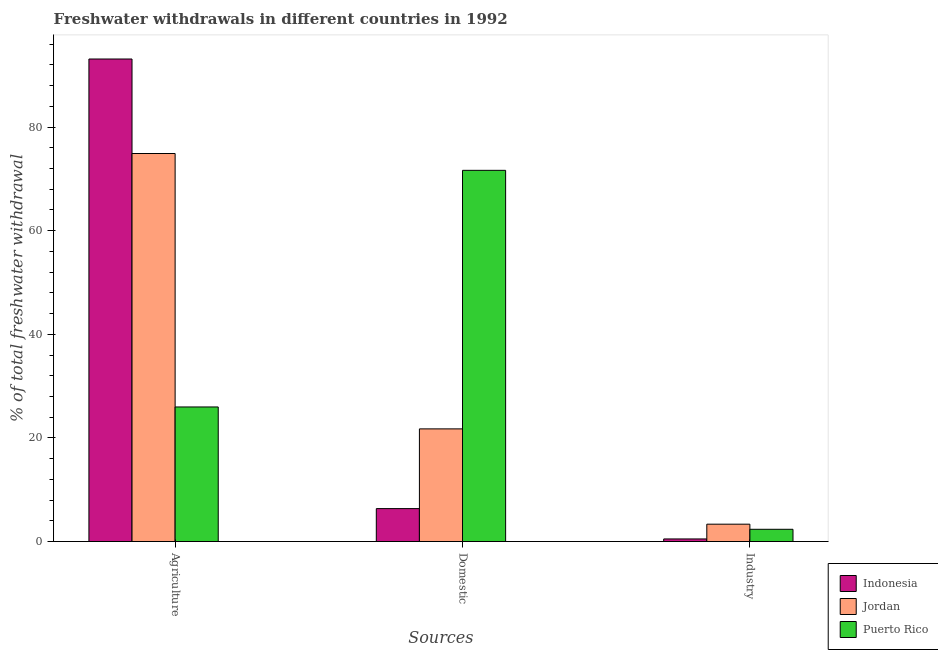How many groups of bars are there?
Provide a short and direct response. 3. How many bars are there on the 1st tick from the left?
Your answer should be compact. 3. How many bars are there on the 3rd tick from the right?
Offer a very short reply. 3. What is the label of the 3rd group of bars from the left?
Provide a succinct answer. Industry. What is the percentage of freshwater withdrawal for agriculture in Indonesia?
Your answer should be compact. 93.14. Across all countries, what is the maximum percentage of freshwater withdrawal for domestic purposes?
Offer a very short reply. 71.65. Across all countries, what is the minimum percentage of freshwater withdrawal for domestic purposes?
Offer a very short reply. 6.36. In which country was the percentage of freshwater withdrawal for industry maximum?
Make the answer very short. Jordan. In which country was the percentage of freshwater withdrawal for agriculture minimum?
Ensure brevity in your answer.  Puerto Rico. What is the total percentage of freshwater withdrawal for agriculture in the graph?
Ensure brevity in your answer.  194.02. What is the difference between the percentage of freshwater withdrawal for agriculture in Indonesia and that in Puerto Rico?
Your response must be concise. 67.16. What is the difference between the percentage of freshwater withdrawal for industry in Jordan and the percentage of freshwater withdrawal for agriculture in Indonesia?
Offer a very short reply. -89.79. What is the average percentage of freshwater withdrawal for industry per country?
Keep it short and to the point. 2.08. What is the difference between the percentage of freshwater withdrawal for domestic purposes and percentage of freshwater withdrawal for agriculture in Jordan?
Your response must be concise. -53.15. What is the ratio of the percentage of freshwater withdrawal for industry in Puerto Rico to that in Indonesia?
Give a very brief answer. 4.68. Is the percentage of freshwater withdrawal for agriculture in Jordan less than that in Indonesia?
Your answer should be compact. Yes. What is the difference between the highest and the second highest percentage of freshwater withdrawal for industry?
Ensure brevity in your answer.  0.99. What is the difference between the highest and the lowest percentage of freshwater withdrawal for domestic purposes?
Provide a short and direct response. 65.29. In how many countries, is the percentage of freshwater withdrawal for industry greater than the average percentage of freshwater withdrawal for industry taken over all countries?
Keep it short and to the point. 2. Is the sum of the percentage of freshwater withdrawal for domestic purposes in Jordan and Indonesia greater than the maximum percentage of freshwater withdrawal for industry across all countries?
Keep it short and to the point. Yes. What does the 3rd bar from the left in Industry represents?
Ensure brevity in your answer.  Puerto Rico. What does the 2nd bar from the right in Agriculture represents?
Your answer should be very brief. Jordan. Are the values on the major ticks of Y-axis written in scientific E-notation?
Provide a succinct answer. No. Does the graph contain any zero values?
Your answer should be compact. No. Does the graph contain grids?
Your response must be concise. No. Where does the legend appear in the graph?
Provide a short and direct response. Bottom right. How many legend labels are there?
Offer a very short reply. 3. What is the title of the graph?
Ensure brevity in your answer.  Freshwater withdrawals in different countries in 1992. What is the label or title of the X-axis?
Make the answer very short. Sources. What is the label or title of the Y-axis?
Offer a terse response. % of total freshwater withdrawal. What is the % of total freshwater withdrawal in Indonesia in Agriculture?
Provide a succinct answer. 93.14. What is the % of total freshwater withdrawal in Jordan in Agriculture?
Make the answer very short. 74.9. What is the % of total freshwater withdrawal of Puerto Rico in Agriculture?
Make the answer very short. 25.98. What is the % of total freshwater withdrawal in Indonesia in Domestic?
Make the answer very short. 6.36. What is the % of total freshwater withdrawal of Jordan in Domestic?
Your answer should be compact. 21.75. What is the % of total freshwater withdrawal of Puerto Rico in Domestic?
Give a very brief answer. 71.65. What is the % of total freshwater withdrawal in Indonesia in Industry?
Your answer should be compact. 0.51. What is the % of total freshwater withdrawal in Jordan in Industry?
Make the answer very short. 3.35. What is the % of total freshwater withdrawal of Puerto Rico in Industry?
Your answer should be compact. 2.37. Across all Sources, what is the maximum % of total freshwater withdrawal in Indonesia?
Your answer should be very brief. 93.14. Across all Sources, what is the maximum % of total freshwater withdrawal of Jordan?
Give a very brief answer. 74.9. Across all Sources, what is the maximum % of total freshwater withdrawal in Puerto Rico?
Provide a short and direct response. 71.65. Across all Sources, what is the minimum % of total freshwater withdrawal in Indonesia?
Ensure brevity in your answer.  0.51. Across all Sources, what is the minimum % of total freshwater withdrawal in Jordan?
Make the answer very short. 3.35. Across all Sources, what is the minimum % of total freshwater withdrawal in Puerto Rico?
Ensure brevity in your answer.  2.37. What is the total % of total freshwater withdrawal in Indonesia in the graph?
Give a very brief answer. 100.01. What is the total % of total freshwater withdrawal of Jordan in the graph?
Ensure brevity in your answer.  100. What is the total % of total freshwater withdrawal in Puerto Rico in the graph?
Your answer should be compact. 100. What is the difference between the % of total freshwater withdrawal in Indonesia in Agriculture and that in Domestic?
Your answer should be very brief. 86.78. What is the difference between the % of total freshwater withdrawal in Jordan in Agriculture and that in Domestic?
Your answer should be very brief. 53.15. What is the difference between the % of total freshwater withdrawal of Puerto Rico in Agriculture and that in Domestic?
Your answer should be compact. -45.67. What is the difference between the % of total freshwater withdrawal of Indonesia in Agriculture and that in Industry?
Your response must be concise. 92.63. What is the difference between the % of total freshwater withdrawal in Jordan in Agriculture and that in Industry?
Your answer should be compact. 71.55. What is the difference between the % of total freshwater withdrawal in Puerto Rico in Agriculture and that in Industry?
Keep it short and to the point. 23.61. What is the difference between the % of total freshwater withdrawal in Indonesia in Domestic and that in Industry?
Your answer should be very brief. 5.86. What is the difference between the % of total freshwater withdrawal in Jordan in Domestic and that in Industry?
Keep it short and to the point. 18.4. What is the difference between the % of total freshwater withdrawal of Puerto Rico in Domestic and that in Industry?
Ensure brevity in your answer.  69.28. What is the difference between the % of total freshwater withdrawal in Indonesia in Agriculture and the % of total freshwater withdrawal in Jordan in Domestic?
Make the answer very short. 71.39. What is the difference between the % of total freshwater withdrawal of Indonesia in Agriculture and the % of total freshwater withdrawal of Puerto Rico in Domestic?
Give a very brief answer. 21.49. What is the difference between the % of total freshwater withdrawal in Jordan in Agriculture and the % of total freshwater withdrawal in Puerto Rico in Domestic?
Your response must be concise. 3.25. What is the difference between the % of total freshwater withdrawal in Indonesia in Agriculture and the % of total freshwater withdrawal in Jordan in Industry?
Keep it short and to the point. 89.79. What is the difference between the % of total freshwater withdrawal in Indonesia in Agriculture and the % of total freshwater withdrawal in Puerto Rico in Industry?
Provide a succinct answer. 90.77. What is the difference between the % of total freshwater withdrawal in Jordan in Agriculture and the % of total freshwater withdrawal in Puerto Rico in Industry?
Ensure brevity in your answer.  72.53. What is the difference between the % of total freshwater withdrawal of Indonesia in Domestic and the % of total freshwater withdrawal of Jordan in Industry?
Provide a succinct answer. 3.01. What is the difference between the % of total freshwater withdrawal in Indonesia in Domestic and the % of total freshwater withdrawal in Puerto Rico in Industry?
Provide a succinct answer. 3.99. What is the difference between the % of total freshwater withdrawal in Jordan in Domestic and the % of total freshwater withdrawal in Puerto Rico in Industry?
Offer a terse response. 19.38. What is the average % of total freshwater withdrawal of Indonesia per Sources?
Provide a short and direct response. 33.34. What is the average % of total freshwater withdrawal in Jordan per Sources?
Your answer should be very brief. 33.33. What is the average % of total freshwater withdrawal of Puerto Rico per Sources?
Your answer should be compact. 33.33. What is the difference between the % of total freshwater withdrawal in Indonesia and % of total freshwater withdrawal in Jordan in Agriculture?
Your answer should be very brief. 18.24. What is the difference between the % of total freshwater withdrawal in Indonesia and % of total freshwater withdrawal in Puerto Rico in Agriculture?
Offer a very short reply. 67.16. What is the difference between the % of total freshwater withdrawal of Jordan and % of total freshwater withdrawal of Puerto Rico in Agriculture?
Offer a very short reply. 48.92. What is the difference between the % of total freshwater withdrawal of Indonesia and % of total freshwater withdrawal of Jordan in Domestic?
Ensure brevity in your answer.  -15.39. What is the difference between the % of total freshwater withdrawal in Indonesia and % of total freshwater withdrawal in Puerto Rico in Domestic?
Provide a short and direct response. -65.29. What is the difference between the % of total freshwater withdrawal in Jordan and % of total freshwater withdrawal in Puerto Rico in Domestic?
Give a very brief answer. -49.9. What is the difference between the % of total freshwater withdrawal of Indonesia and % of total freshwater withdrawal of Jordan in Industry?
Your answer should be compact. -2.85. What is the difference between the % of total freshwater withdrawal of Indonesia and % of total freshwater withdrawal of Puerto Rico in Industry?
Your answer should be very brief. -1.86. What is the ratio of the % of total freshwater withdrawal in Indonesia in Agriculture to that in Domestic?
Offer a terse response. 14.64. What is the ratio of the % of total freshwater withdrawal in Jordan in Agriculture to that in Domestic?
Ensure brevity in your answer.  3.44. What is the ratio of the % of total freshwater withdrawal in Puerto Rico in Agriculture to that in Domestic?
Provide a succinct answer. 0.36. What is the ratio of the % of total freshwater withdrawal of Indonesia in Agriculture to that in Industry?
Provide a succinct answer. 184.14. What is the ratio of the % of total freshwater withdrawal in Jordan in Agriculture to that in Industry?
Your answer should be compact. 22.33. What is the ratio of the % of total freshwater withdrawal in Puerto Rico in Agriculture to that in Industry?
Give a very brief answer. 10.97. What is the ratio of the % of total freshwater withdrawal in Indonesia in Domestic to that in Industry?
Provide a succinct answer. 12.58. What is the ratio of the % of total freshwater withdrawal of Jordan in Domestic to that in Industry?
Provide a short and direct response. 6.48. What is the ratio of the % of total freshwater withdrawal of Puerto Rico in Domestic to that in Industry?
Provide a short and direct response. 30.26. What is the difference between the highest and the second highest % of total freshwater withdrawal in Indonesia?
Give a very brief answer. 86.78. What is the difference between the highest and the second highest % of total freshwater withdrawal of Jordan?
Give a very brief answer. 53.15. What is the difference between the highest and the second highest % of total freshwater withdrawal of Puerto Rico?
Give a very brief answer. 45.67. What is the difference between the highest and the lowest % of total freshwater withdrawal of Indonesia?
Your answer should be very brief. 92.63. What is the difference between the highest and the lowest % of total freshwater withdrawal of Jordan?
Offer a terse response. 71.55. What is the difference between the highest and the lowest % of total freshwater withdrawal in Puerto Rico?
Offer a very short reply. 69.28. 